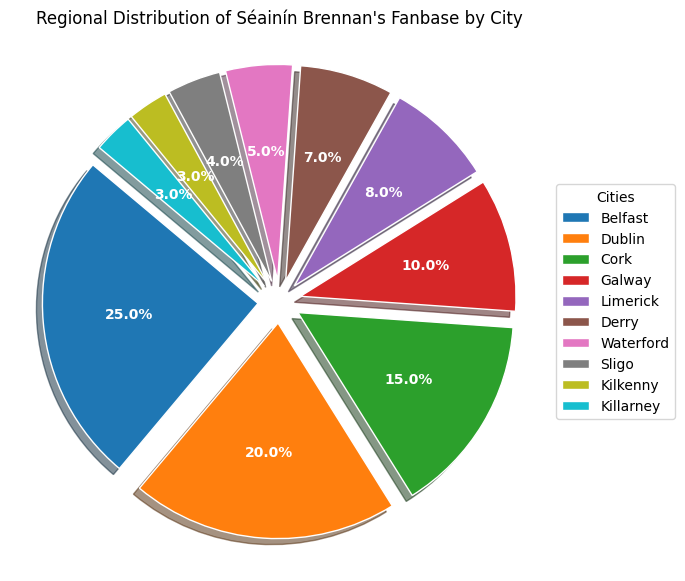What percentage of Séainín Brennan's fanbase comes from Belfast? The pie chart shows individual sections with labels indicating the percentage of the fanbase for each city. The section labeled "Belfast" corresponds to 25%.
Answer: 25% Which city has the second-largest fanbase for Séainín Brennan? By observing the percentages on the pie chart, the city with the largest fanbase is Belfast at 25%, followed by Dublin at 20%.
Answer: Dublin What is the combined fanbase percentage for Cork, Galway, and Limerick? Look at the pie chart sections labeled Cork, Galway, and Limerick. Cork has 15%, Galway has 10%, and Limerick has 8%. Summing these percentages: 15% + 10% + 8% = 33%.
Answer: 33% How much greater is the fanbase percentage of Belfast compared to Killarney? From the pie chart, Belfast has 25% and Killarney has 3%. Subtract the percentage of Killarney from Belfast: 25% - 3% = 22%.
Answer: 22% Is the fanbase in Waterford larger or smaller than Derry? Refer to the pie chart where Waterford is at 5% and Derry is at 7%. Since 5% is smaller than 7%, Waterford has a smaller fanbase.
Answer: Smaller What is the average percentage of the fanbases for Sligo, Kilkenny, and Killarney? The chart shows that Sligo has 4%, Kilkenny has 3%, and Killarney has 3%. Calculate the average of these percentages: (4% + 3% + 3%) / 3 = 3.33%.
Answer: 3.33% Which cities have a fanbase percentage that totals less than 10% when combined? From the chart, the cities with lower percentages are Waterford (5%), Sligo (4%), Kilkenny (3%), and Killarney (3%). Summing the smallest values: Waterford + Sligo = 5% + 4% = 9%, which is less than 10%. Thus, Waterford and Sligo combined meet this criterion.
Answer: Waterford and Sligo How many cities have a fanbase percentage that is less than 8%? Checking the chart, the cities with percentages less than 8% are Derry (7%), Waterford (5%), Sligo (4%), Kilkenny (3%), and Killarney (3%). This gives a total of five cities.
Answer: 5 Which section of the pie chart would have the largest slice if it wasn't exploded? The pie chart visually indicates the largest section by its overall size and percentage. The section representing Belfast, with 25%, is the largest.
Answer: Belfast 